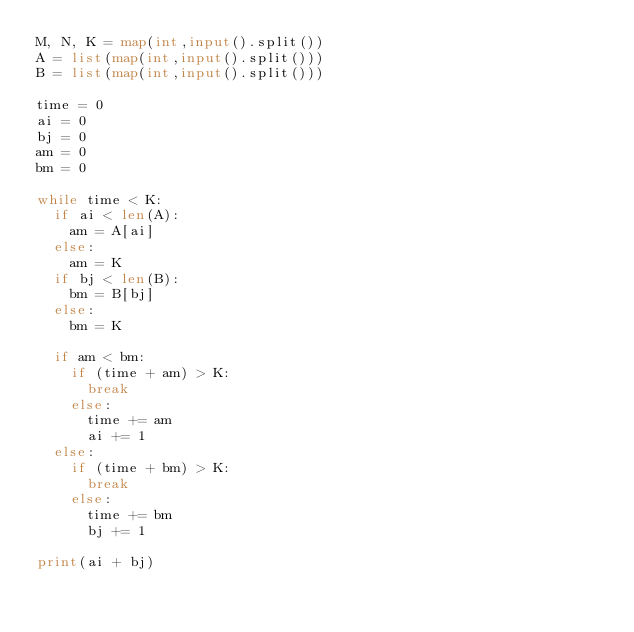<code> <loc_0><loc_0><loc_500><loc_500><_Python_>M, N, K = map(int,input().split())
A = list(map(int,input().split()))
B = list(map(int,input().split()))

time = 0
ai = 0
bj = 0
am = 0
bm = 0

while time < K:
  if ai < len(A):
    am = A[ai]
  else:
    am = K
  if bj < len(B):
    bm = B[bj]
  else:
    bm = K

  if am < bm:
    if (time + am) > K:
      break
    else:
      time += am
      ai += 1
  else:
    if (time + bm) > K:
      break
    else:
      time += bm
      bj += 1

print(ai + bj)
</code> 